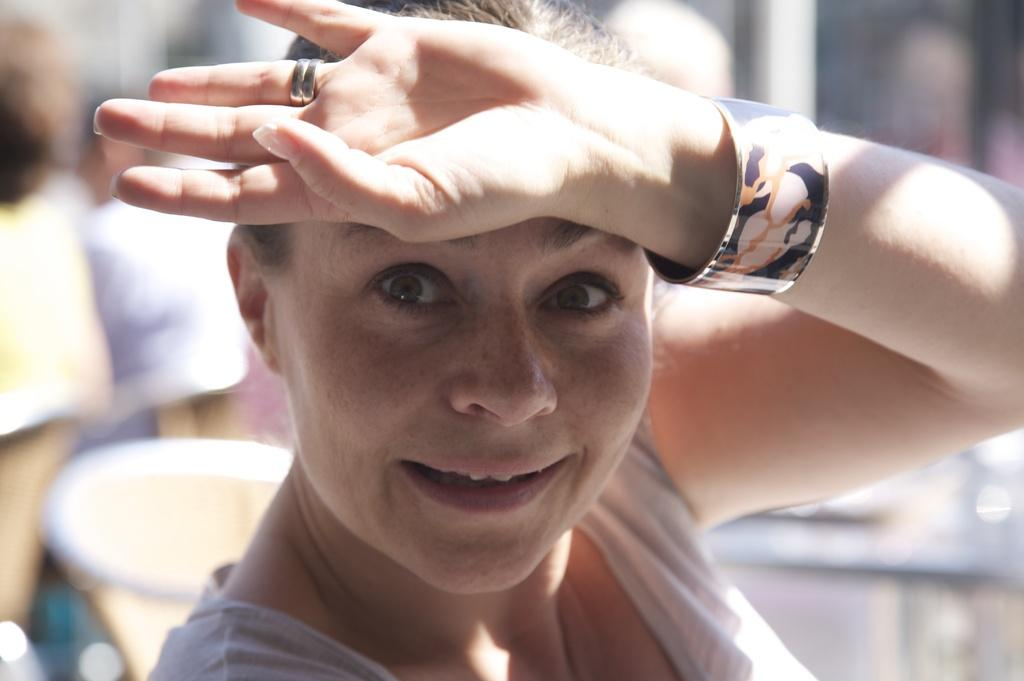Who is the main subject in the image? There is a woman in the middle of the image. What can be observed about the background of the image? The background of the image is completely blurred. What type of shoe is the woman wearing in the image? There is no shoe visible in the image, as the woman is the main subject and the background is completely blurred. 